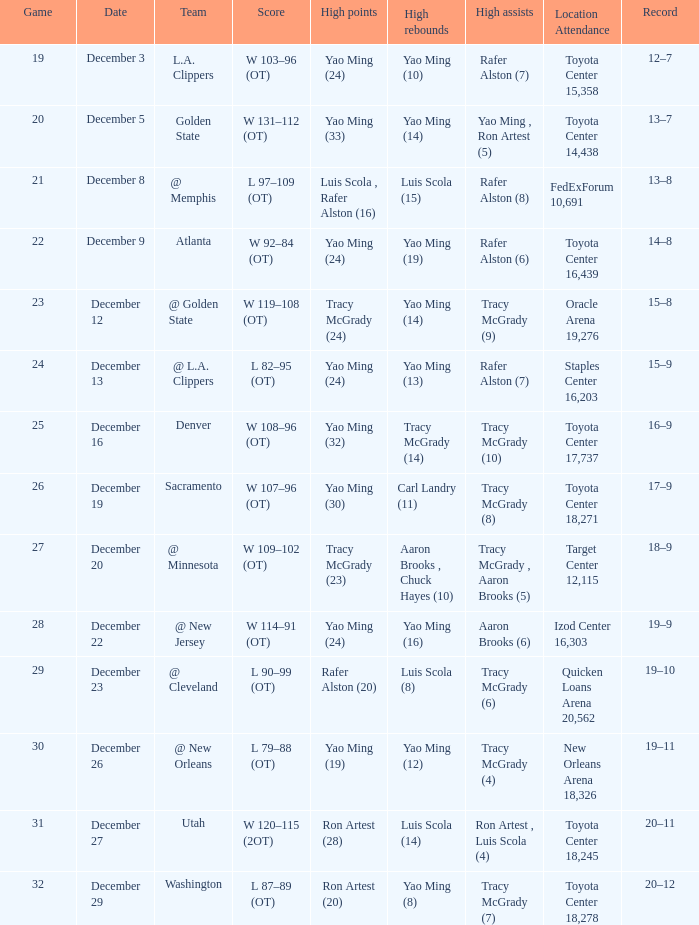When did aaron brooks (6) record the most assists on a specific date? December 22. 